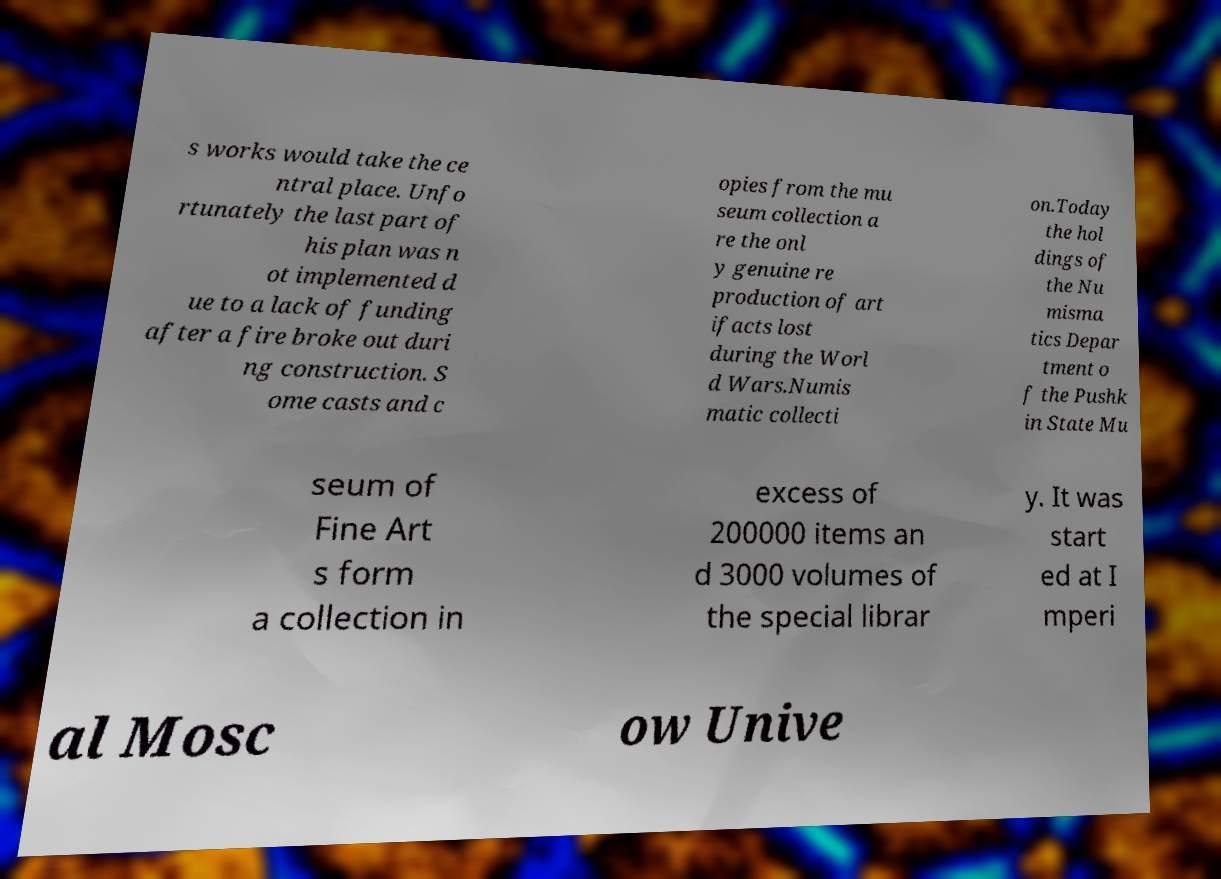Can you accurately transcribe the text from the provided image for me? s works would take the ce ntral place. Unfo rtunately the last part of his plan was n ot implemented d ue to a lack of funding after a fire broke out duri ng construction. S ome casts and c opies from the mu seum collection a re the onl y genuine re production of art ifacts lost during the Worl d Wars.Numis matic collecti on.Today the hol dings of the Nu misma tics Depar tment o f the Pushk in State Mu seum of Fine Art s form a collection in excess of 200000 items an d 3000 volumes of the special librar y. It was start ed at I mperi al Mosc ow Unive 